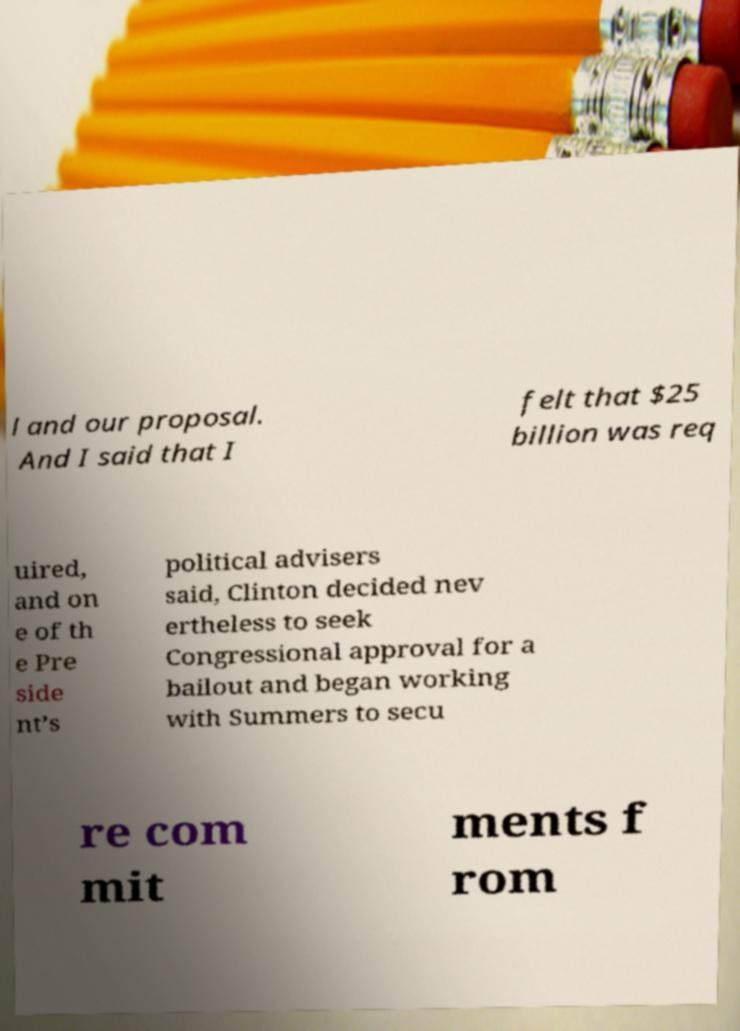For documentation purposes, I need the text within this image transcribed. Could you provide that? l and our proposal. And I said that I felt that $25 billion was req uired, and on e of th e Pre side nt’s political advisers said, Clinton decided nev ertheless to seek Congressional approval for a bailout and began working with Summers to secu re com mit ments f rom 